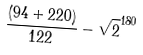Convert formula to latex. <formula><loc_0><loc_0><loc_500><loc_500>\frac { ( 9 4 + 2 2 0 ) } { 1 2 2 } - \sqrt { 2 } ^ { 1 8 0 }</formula> 